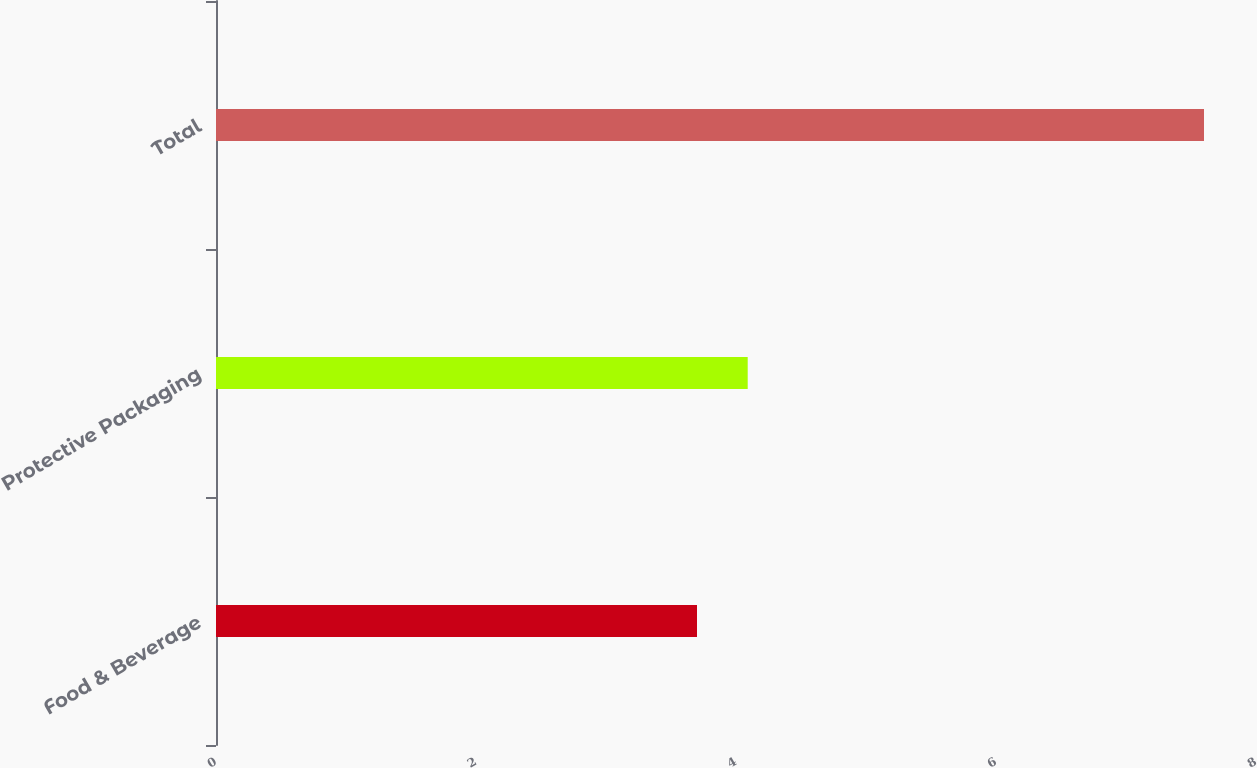<chart> <loc_0><loc_0><loc_500><loc_500><bar_chart><fcel>Food & Beverage<fcel>Protective Packaging<fcel>Total<nl><fcel>3.7<fcel>4.09<fcel>7.6<nl></chart> 